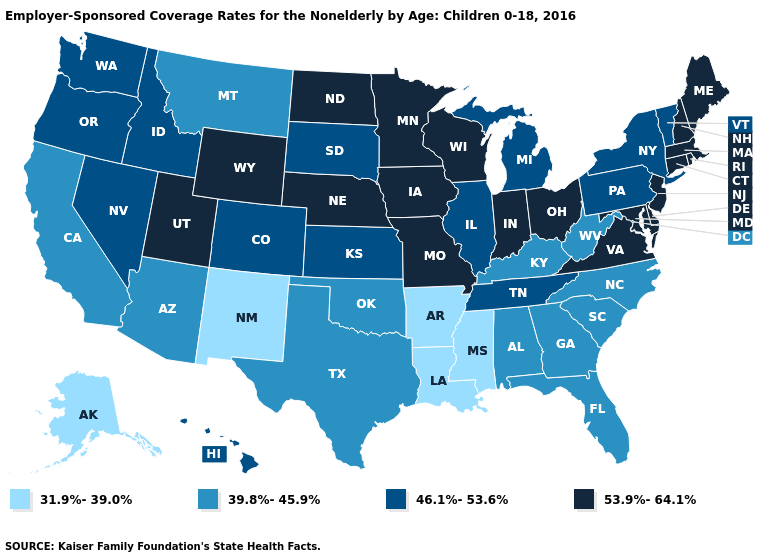Does Maine have the highest value in the Northeast?
Write a very short answer. Yes. Which states have the highest value in the USA?
Quick response, please. Connecticut, Delaware, Indiana, Iowa, Maine, Maryland, Massachusetts, Minnesota, Missouri, Nebraska, New Hampshire, New Jersey, North Dakota, Ohio, Rhode Island, Utah, Virginia, Wisconsin, Wyoming. What is the lowest value in the USA?
Answer briefly. 31.9%-39.0%. What is the value of Connecticut?
Quick response, please. 53.9%-64.1%. Name the states that have a value in the range 53.9%-64.1%?
Keep it brief. Connecticut, Delaware, Indiana, Iowa, Maine, Maryland, Massachusetts, Minnesota, Missouri, Nebraska, New Hampshire, New Jersey, North Dakota, Ohio, Rhode Island, Utah, Virginia, Wisconsin, Wyoming. Does New Hampshire have the lowest value in the Northeast?
Give a very brief answer. No. Does Wyoming have a higher value than Rhode Island?
Give a very brief answer. No. What is the highest value in states that border Minnesota?
Short answer required. 53.9%-64.1%. How many symbols are there in the legend?
Be succinct. 4. What is the lowest value in the MidWest?
Give a very brief answer. 46.1%-53.6%. What is the value of Vermont?
Answer briefly. 46.1%-53.6%. What is the lowest value in the USA?
Give a very brief answer. 31.9%-39.0%. How many symbols are there in the legend?
Short answer required. 4. Which states hav the highest value in the MidWest?
Give a very brief answer. Indiana, Iowa, Minnesota, Missouri, Nebraska, North Dakota, Ohio, Wisconsin. 